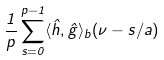<formula> <loc_0><loc_0><loc_500><loc_500>\frac { 1 } { p } \sum _ { s = 0 } ^ { p - 1 } \langle \hat { h } , \hat { g } \rangle _ { b } ( \nu - s / a )</formula> 